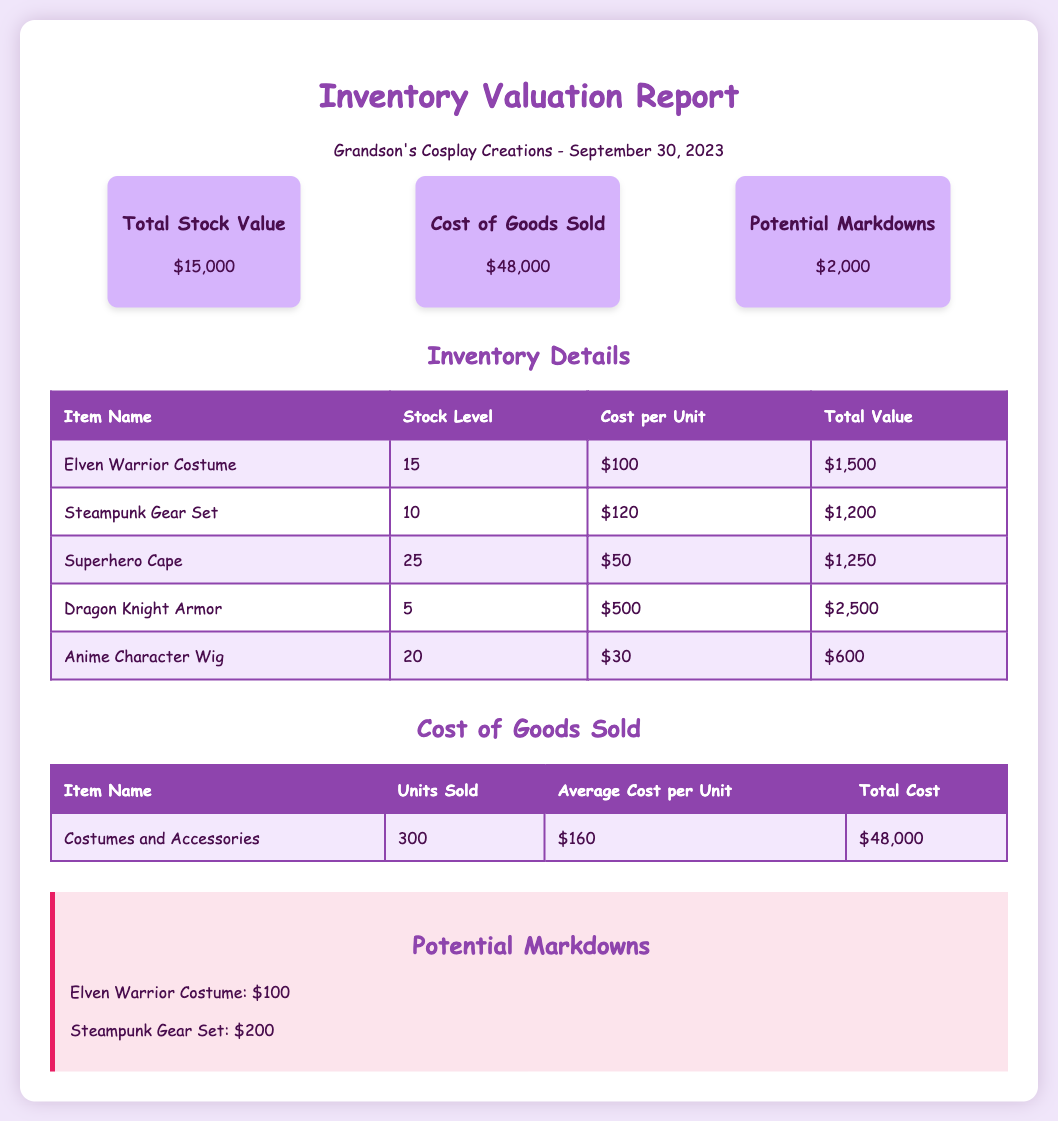what is the total stock value? The total stock value is presented in the summary section of the document as $15,000.
Answer: $15,000 how many units of the Elven Warrior Costume are in stock? The stock level for the Elven Warrior Costume is indicated in the inventory details table as 15 units.
Answer: 15 what is the total cost of goods sold? The total cost of goods sold is stated in the summary section as $48,000.
Answer: $48,000 what is the potential markdown amount for the Steampunk Gear Set? The potential markdown for the Steampunk Gear Set is specified in the markdown section as $200.
Answer: $200 how many units of costumes and accessories were sold? The document states that 300 units of costumes and accessories were sold in the cost of goods sold section.
Answer: 300 what is the total value of the Dragon Knight Armor? The total value of the Dragon Knight Armor is listed in the inventory details as $2,500.
Answer: $2,500 what is the average cost per unit of costumes and accessories sold? The average cost per unit of costumes and accessories is mentioned as $160 in the cost of goods sold section.
Answer: $160 what is the stock level for anime character wigs? The inventory details indicate that there are 20 units of anime character wigs in stock.
Answer: 20 how much is the potential markdown for the Elven Warrior Costume? The potential markdown for the Elven Warrior Costume is detailed as $100 in the markdown section.
Answer: $100 